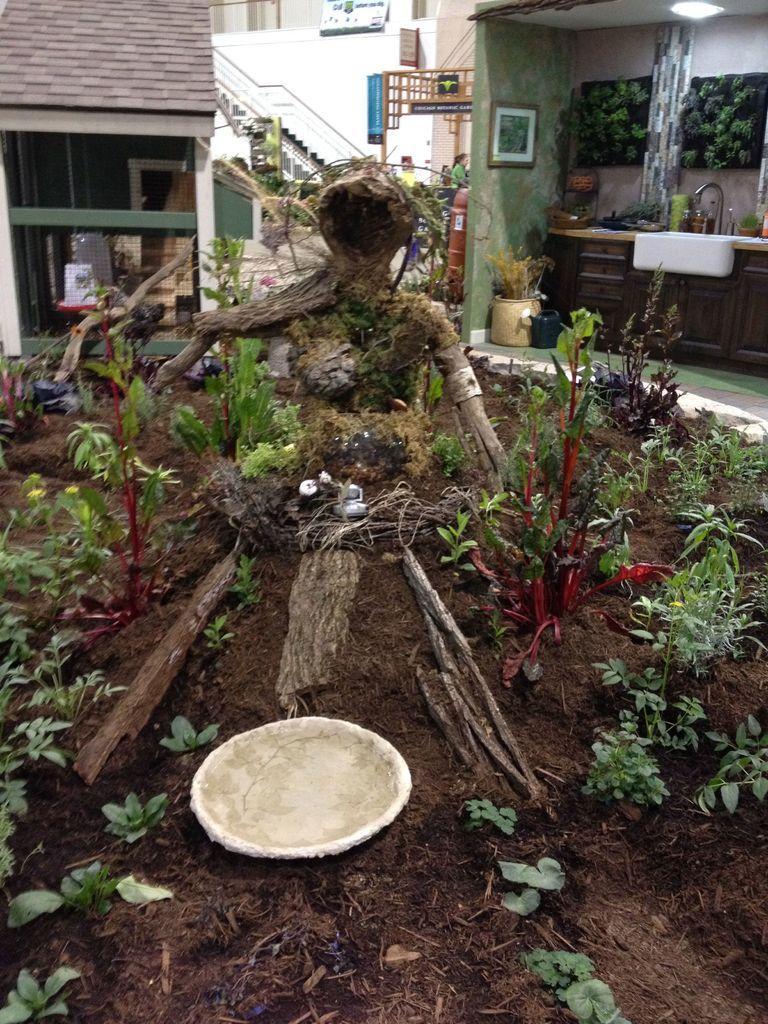Can you describe this image briefly? In this image we can see a wooden statue and plants. Background of the image kitchen, stairs and house is there. 